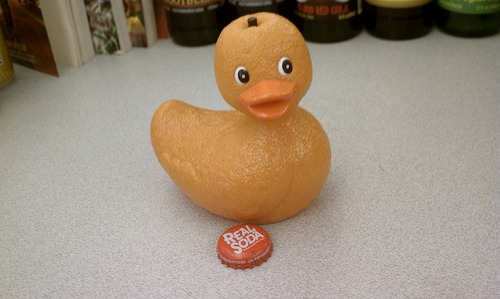<image>
Can you confirm if the duck is above the bottle cap? No. The duck is not positioned above the bottle cap. The vertical arrangement shows a different relationship. 